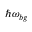Convert formula to latex. <formula><loc_0><loc_0><loc_500><loc_500>\hbar { \omega } _ { b g }</formula> 